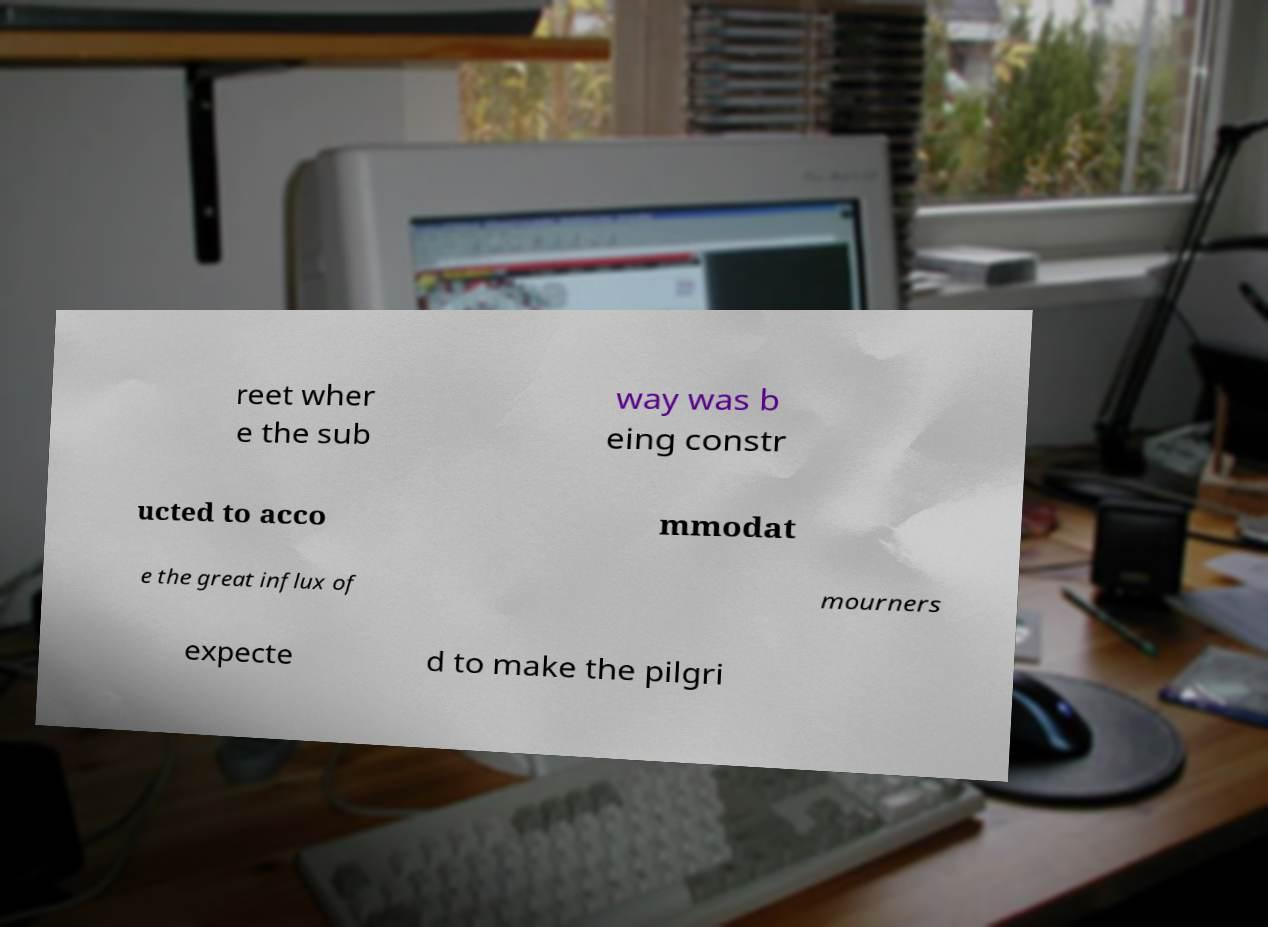Can you read and provide the text displayed in the image?This photo seems to have some interesting text. Can you extract and type it out for me? reet wher e the sub way was b eing constr ucted to acco mmodat e the great influx of mourners expecte d to make the pilgri 